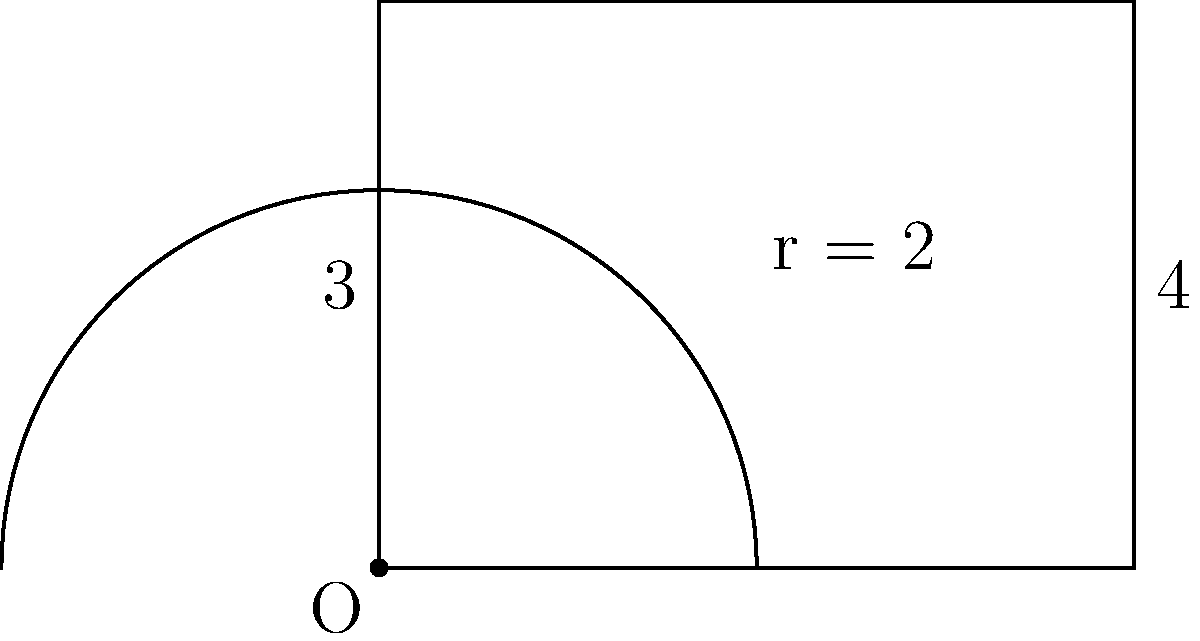Calculate the total area of the shape shown in the diagram. The shape consists of a rectangle with a semicircle on top. The rectangle has a width of 4 units and a height of 3 units. The radius of the semicircle is 2 units. To find the total area, we need to calculate the areas of the rectangle and the semicircle separately, then add them together.

1. Area of the rectangle:
   $$A_{rectangle} = width \times height = 4 \times 3 = 12\text{ square units}$$

2. Area of the semicircle:
   The formula for the area of a circle is $\pi r^2$, so for a semicircle, we use half of this.
   $$A_{semicircle} = \frac{1}{2} \pi r^2 = \frac{1}{2} \times \pi \times 2^2 = 2\pi\text{ square units}$$

3. Total area:
   $$A_{total} = A_{rectangle} + A_{semicircle} = 12 + 2\pi\text{ square units}$$

4. Simplifying the result:
   $$A_{total} = 12 + 2\pi \approx 18.28\text{ square units}$$
Answer: $12 + 2\pi$ square units 